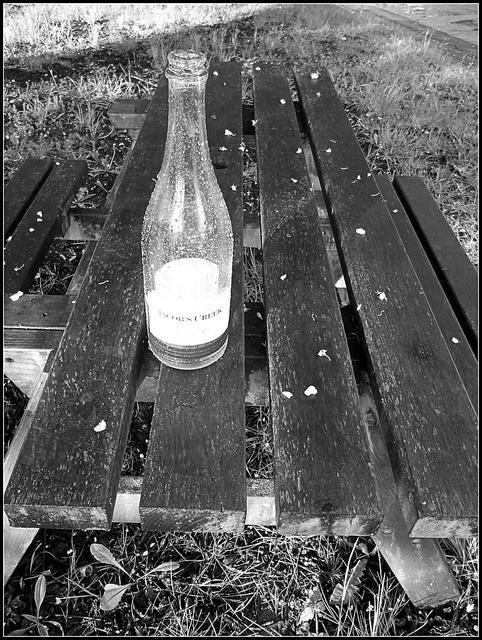How many people are getting in motors?
Give a very brief answer. 0. 